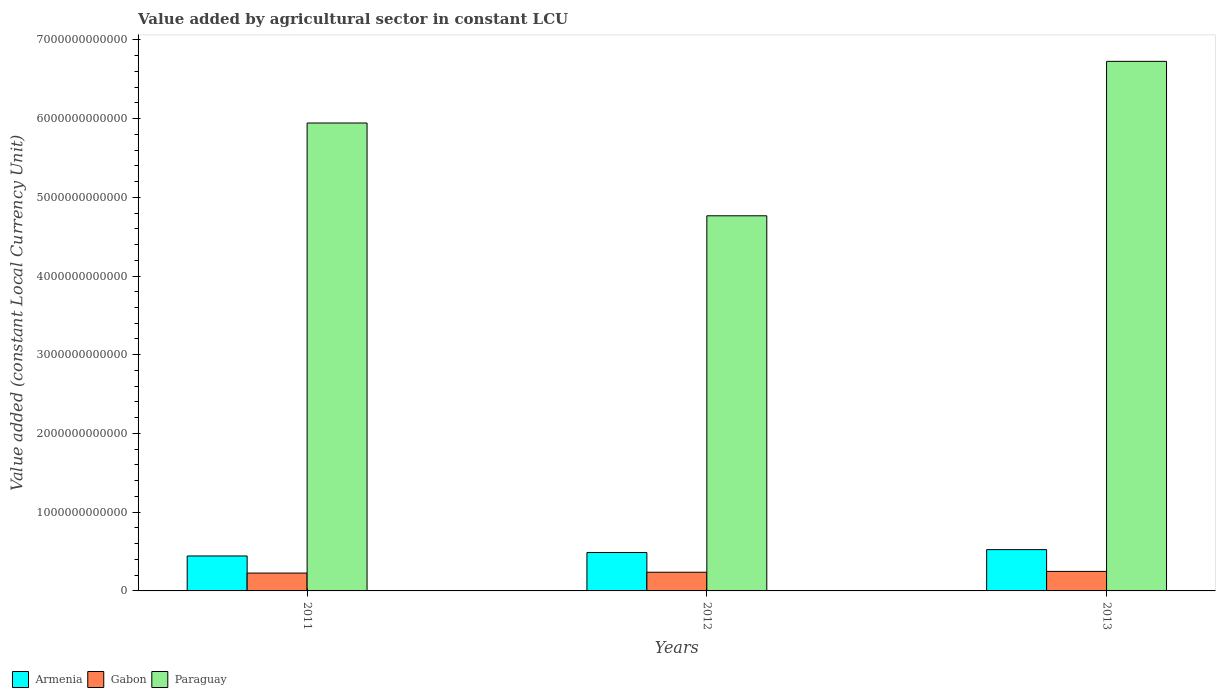How many different coloured bars are there?
Keep it short and to the point. 3. Are the number of bars per tick equal to the number of legend labels?
Offer a terse response. Yes. Are the number of bars on each tick of the X-axis equal?
Provide a succinct answer. Yes. How many bars are there on the 2nd tick from the left?
Ensure brevity in your answer.  3. How many bars are there on the 3rd tick from the right?
Offer a very short reply. 3. What is the label of the 2nd group of bars from the left?
Ensure brevity in your answer.  2012. What is the value added by agricultural sector in Paraguay in 2013?
Ensure brevity in your answer.  6.73e+12. Across all years, what is the maximum value added by agricultural sector in Gabon?
Keep it short and to the point. 2.48e+11. Across all years, what is the minimum value added by agricultural sector in Armenia?
Your answer should be very brief. 4.44e+11. In which year was the value added by agricultural sector in Gabon minimum?
Your answer should be compact. 2011. What is the total value added by agricultural sector in Paraguay in the graph?
Your answer should be very brief. 1.74e+13. What is the difference between the value added by agricultural sector in Paraguay in 2011 and that in 2013?
Ensure brevity in your answer.  -7.83e+11. What is the difference between the value added by agricultural sector in Paraguay in 2012 and the value added by agricultural sector in Gabon in 2013?
Provide a succinct answer. 4.52e+12. What is the average value added by agricultural sector in Gabon per year?
Your answer should be very brief. 2.37e+11. In the year 2011, what is the difference between the value added by agricultural sector in Gabon and value added by agricultural sector in Armenia?
Provide a succinct answer. -2.17e+11. What is the ratio of the value added by agricultural sector in Armenia in 2012 to that in 2013?
Make the answer very short. 0.93. Is the value added by agricultural sector in Gabon in 2012 less than that in 2013?
Give a very brief answer. Yes. What is the difference between the highest and the second highest value added by agricultural sector in Gabon?
Provide a succinct answer. 1.08e+1. What is the difference between the highest and the lowest value added by agricultural sector in Gabon?
Provide a short and direct response. 2.14e+1. In how many years, is the value added by agricultural sector in Paraguay greater than the average value added by agricultural sector in Paraguay taken over all years?
Your response must be concise. 2. Is the sum of the value added by agricultural sector in Gabon in 2012 and 2013 greater than the maximum value added by agricultural sector in Armenia across all years?
Make the answer very short. No. What does the 1st bar from the left in 2011 represents?
Make the answer very short. Armenia. What does the 3rd bar from the right in 2013 represents?
Ensure brevity in your answer.  Armenia. Is it the case that in every year, the sum of the value added by agricultural sector in Paraguay and value added by agricultural sector in Armenia is greater than the value added by agricultural sector in Gabon?
Provide a short and direct response. Yes. Are all the bars in the graph horizontal?
Your answer should be compact. No. What is the difference between two consecutive major ticks on the Y-axis?
Provide a short and direct response. 1.00e+12. Does the graph contain any zero values?
Offer a very short reply. No. Where does the legend appear in the graph?
Keep it short and to the point. Bottom left. How many legend labels are there?
Keep it short and to the point. 3. What is the title of the graph?
Make the answer very short. Value added by agricultural sector in constant LCU. Does "OECD members" appear as one of the legend labels in the graph?
Ensure brevity in your answer.  No. What is the label or title of the X-axis?
Offer a terse response. Years. What is the label or title of the Y-axis?
Keep it short and to the point. Value added (constant Local Currency Unit). What is the Value added (constant Local Currency Unit) of Armenia in 2011?
Offer a terse response. 4.44e+11. What is the Value added (constant Local Currency Unit) in Gabon in 2011?
Provide a succinct answer. 2.27e+11. What is the Value added (constant Local Currency Unit) in Paraguay in 2011?
Your answer should be very brief. 5.94e+12. What is the Value added (constant Local Currency Unit) of Armenia in 2012?
Offer a very short reply. 4.88e+11. What is the Value added (constant Local Currency Unit) of Gabon in 2012?
Your response must be concise. 2.37e+11. What is the Value added (constant Local Currency Unit) in Paraguay in 2012?
Your response must be concise. 4.77e+12. What is the Value added (constant Local Currency Unit) of Armenia in 2013?
Your answer should be very brief. 5.25e+11. What is the Value added (constant Local Currency Unit) of Gabon in 2013?
Give a very brief answer. 2.48e+11. What is the Value added (constant Local Currency Unit) of Paraguay in 2013?
Your answer should be very brief. 6.73e+12. Across all years, what is the maximum Value added (constant Local Currency Unit) of Armenia?
Your answer should be very brief. 5.25e+11. Across all years, what is the maximum Value added (constant Local Currency Unit) of Gabon?
Offer a very short reply. 2.48e+11. Across all years, what is the maximum Value added (constant Local Currency Unit) of Paraguay?
Keep it short and to the point. 6.73e+12. Across all years, what is the minimum Value added (constant Local Currency Unit) of Armenia?
Your response must be concise. 4.44e+11. Across all years, what is the minimum Value added (constant Local Currency Unit) of Gabon?
Your response must be concise. 2.27e+11. Across all years, what is the minimum Value added (constant Local Currency Unit) of Paraguay?
Provide a succinct answer. 4.77e+12. What is the total Value added (constant Local Currency Unit) of Armenia in the graph?
Your answer should be very brief. 1.46e+12. What is the total Value added (constant Local Currency Unit) of Gabon in the graph?
Your answer should be very brief. 7.12e+11. What is the total Value added (constant Local Currency Unit) in Paraguay in the graph?
Your answer should be compact. 1.74e+13. What is the difference between the Value added (constant Local Currency Unit) in Armenia in 2011 and that in 2012?
Give a very brief answer. -4.39e+1. What is the difference between the Value added (constant Local Currency Unit) in Gabon in 2011 and that in 2012?
Provide a succinct answer. -1.06e+1. What is the difference between the Value added (constant Local Currency Unit) in Paraguay in 2011 and that in 2012?
Your answer should be very brief. 1.18e+12. What is the difference between the Value added (constant Local Currency Unit) of Armenia in 2011 and that in 2013?
Your answer should be very brief. -8.09e+1. What is the difference between the Value added (constant Local Currency Unit) in Gabon in 2011 and that in 2013?
Your answer should be very brief. -2.14e+1. What is the difference between the Value added (constant Local Currency Unit) of Paraguay in 2011 and that in 2013?
Your answer should be compact. -7.83e+11. What is the difference between the Value added (constant Local Currency Unit) of Armenia in 2012 and that in 2013?
Make the answer very short. -3.71e+1. What is the difference between the Value added (constant Local Currency Unit) of Gabon in 2012 and that in 2013?
Offer a very short reply. -1.08e+1. What is the difference between the Value added (constant Local Currency Unit) in Paraguay in 2012 and that in 2013?
Offer a very short reply. -1.96e+12. What is the difference between the Value added (constant Local Currency Unit) in Armenia in 2011 and the Value added (constant Local Currency Unit) in Gabon in 2012?
Offer a terse response. 2.06e+11. What is the difference between the Value added (constant Local Currency Unit) in Armenia in 2011 and the Value added (constant Local Currency Unit) in Paraguay in 2012?
Provide a succinct answer. -4.32e+12. What is the difference between the Value added (constant Local Currency Unit) in Gabon in 2011 and the Value added (constant Local Currency Unit) in Paraguay in 2012?
Your answer should be compact. -4.54e+12. What is the difference between the Value added (constant Local Currency Unit) in Armenia in 2011 and the Value added (constant Local Currency Unit) in Gabon in 2013?
Ensure brevity in your answer.  1.96e+11. What is the difference between the Value added (constant Local Currency Unit) of Armenia in 2011 and the Value added (constant Local Currency Unit) of Paraguay in 2013?
Your answer should be very brief. -6.28e+12. What is the difference between the Value added (constant Local Currency Unit) in Gabon in 2011 and the Value added (constant Local Currency Unit) in Paraguay in 2013?
Make the answer very short. -6.50e+12. What is the difference between the Value added (constant Local Currency Unit) in Armenia in 2012 and the Value added (constant Local Currency Unit) in Gabon in 2013?
Offer a very short reply. 2.40e+11. What is the difference between the Value added (constant Local Currency Unit) in Armenia in 2012 and the Value added (constant Local Currency Unit) in Paraguay in 2013?
Give a very brief answer. -6.24e+12. What is the difference between the Value added (constant Local Currency Unit) of Gabon in 2012 and the Value added (constant Local Currency Unit) of Paraguay in 2013?
Provide a succinct answer. -6.49e+12. What is the average Value added (constant Local Currency Unit) of Armenia per year?
Make the answer very short. 4.85e+11. What is the average Value added (constant Local Currency Unit) in Gabon per year?
Offer a terse response. 2.37e+11. What is the average Value added (constant Local Currency Unit) in Paraguay per year?
Give a very brief answer. 5.81e+12. In the year 2011, what is the difference between the Value added (constant Local Currency Unit) in Armenia and Value added (constant Local Currency Unit) in Gabon?
Provide a short and direct response. 2.17e+11. In the year 2011, what is the difference between the Value added (constant Local Currency Unit) of Armenia and Value added (constant Local Currency Unit) of Paraguay?
Give a very brief answer. -5.50e+12. In the year 2011, what is the difference between the Value added (constant Local Currency Unit) in Gabon and Value added (constant Local Currency Unit) in Paraguay?
Provide a succinct answer. -5.72e+12. In the year 2012, what is the difference between the Value added (constant Local Currency Unit) in Armenia and Value added (constant Local Currency Unit) in Gabon?
Make the answer very short. 2.50e+11. In the year 2012, what is the difference between the Value added (constant Local Currency Unit) of Armenia and Value added (constant Local Currency Unit) of Paraguay?
Keep it short and to the point. -4.28e+12. In the year 2012, what is the difference between the Value added (constant Local Currency Unit) of Gabon and Value added (constant Local Currency Unit) of Paraguay?
Keep it short and to the point. -4.53e+12. In the year 2013, what is the difference between the Value added (constant Local Currency Unit) of Armenia and Value added (constant Local Currency Unit) of Gabon?
Provide a short and direct response. 2.77e+11. In the year 2013, what is the difference between the Value added (constant Local Currency Unit) in Armenia and Value added (constant Local Currency Unit) in Paraguay?
Make the answer very short. -6.20e+12. In the year 2013, what is the difference between the Value added (constant Local Currency Unit) in Gabon and Value added (constant Local Currency Unit) in Paraguay?
Ensure brevity in your answer.  -6.48e+12. What is the ratio of the Value added (constant Local Currency Unit) in Armenia in 2011 to that in 2012?
Offer a very short reply. 0.91. What is the ratio of the Value added (constant Local Currency Unit) in Gabon in 2011 to that in 2012?
Offer a very short reply. 0.96. What is the ratio of the Value added (constant Local Currency Unit) of Paraguay in 2011 to that in 2012?
Your response must be concise. 1.25. What is the ratio of the Value added (constant Local Currency Unit) in Armenia in 2011 to that in 2013?
Give a very brief answer. 0.85. What is the ratio of the Value added (constant Local Currency Unit) of Gabon in 2011 to that in 2013?
Your answer should be very brief. 0.91. What is the ratio of the Value added (constant Local Currency Unit) of Paraguay in 2011 to that in 2013?
Offer a very short reply. 0.88. What is the ratio of the Value added (constant Local Currency Unit) in Armenia in 2012 to that in 2013?
Your answer should be very brief. 0.93. What is the ratio of the Value added (constant Local Currency Unit) of Gabon in 2012 to that in 2013?
Your answer should be compact. 0.96. What is the ratio of the Value added (constant Local Currency Unit) of Paraguay in 2012 to that in 2013?
Your response must be concise. 0.71. What is the difference between the highest and the second highest Value added (constant Local Currency Unit) of Armenia?
Ensure brevity in your answer.  3.71e+1. What is the difference between the highest and the second highest Value added (constant Local Currency Unit) in Gabon?
Offer a very short reply. 1.08e+1. What is the difference between the highest and the second highest Value added (constant Local Currency Unit) in Paraguay?
Ensure brevity in your answer.  7.83e+11. What is the difference between the highest and the lowest Value added (constant Local Currency Unit) in Armenia?
Provide a short and direct response. 8.09e+1. What is the difference between the highest and the lowest Value added (constant Local Currency Unit) of Gabon?
Your answer should be very brief. 2.14e+1. What is the difference between the highest and the lowest Value added (constant Local Currency Unit) of Paraguay?
Your answer should be compact. 1.96e+12. 